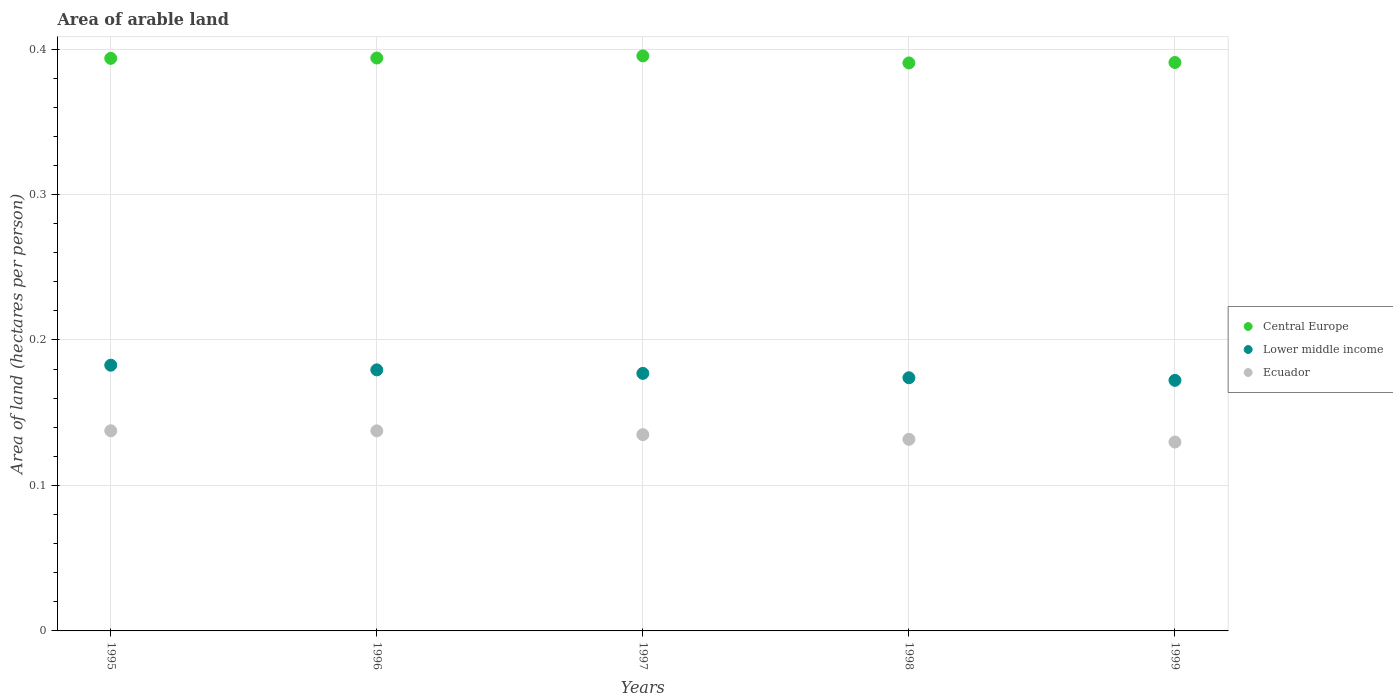What is the total arable land in Lower middle income in 1997?
Provide a succinct answer. 0.18. Across all years, what is the maximum total arable land in Central Europe?
Your answer should be compact. 0.4. Across all years, what is the minimum total arable land in Lower middle income?
Make the answer very short. 0.17. What is the total total arable land in Lower middle income in the graph?
Your answer should be compact. 0.89. What is the difference between the total arable land in Central Europe in 1995 and that in 1998?
Offer a terse response. 0. What is the difference between the total arable land in Lower middle income in 1998 and the total arable land in Ecuador in 1999?
Provide a succinct answer. 0.04. What is the average total arable land in Lower middle income per year?
Provide a short and direct response. 0.18. In the year 1995, what is the difference between the total arable land in Lower middle income and total arable land in Central Europe?
Ensure brevity in your answer.  -0.21. What is the ratio of the total arable land in Lower middle income in 1995 to that in 1998?
Your response must be concise. 1.05. Is the total arable land in Lower middle income in 1995 less than that in 1997?
Offer a terse response. No. What is the difference between the highest and the second highest total arable land in Lower middle income?
Make the answer very short. 0. What is the difference between the highest and the lowest total arable land in Ecuador?
Provide a short and direct response. 0.01. Is it the case that in every year, the sum of the total arable land in Lower middle income and total arable land in Ecuador  is greater than the total arable land in Central Europe?
Offer a terse response. No. Does the total arable land in Central Europe monotonically increase over the years?
Provide a succinct answer. No. Is the total arable land in Central Europe strictly greater than the total arable land in Lower middle income over the years?
Your answer should be compact. Yes. Is the total arable land in Ecuador strictly less than the total arable land in Central Europe over the years?
Your answer should be very brief. Yes. What is the title of the graph?
Make the answer very short. Area of arable land. What is the label or title of the Y-axis?
Keep it short and to the point. Area of land (hectares per person). What is the Area of land (hectares per person) of Central Europe in 1995?
Make the answer very short. 0.39. What is the Area of land (hectares per person) in Lower middle income in 1995?
Make the answer very short. 0.18. What is the Area of land (hectares per person) in Ecuador in 1995?
Give a very brief answer. 0.14. What is the Area of land (hectares per person) of Central Europe in 1996?
Ensure brevity in your answer.  0.39. What is the Area of land (hectares per person) in Lower middle income in 1996?
Keep it short and to the point. 0.18. What is the Area of land (hectares per person) in Ecuador in 1996?
Your response must be concise. 0.14. What is the Area of land (hectares per person) in Central Europe in 1997?
Your response must be concise. 0.4. What is the Area of land (hectares per person) in Lower middle income in 1997?
Provide a succinct answer. 0.18. What is the Area of land (hectares per person) of Ecuador in 1997?
Offer a very short reply. 0.13. What is the Area of land (hectares per person) in Central Europe in 1998?
Provide a short and direct response. 0.39. What is the Area of land (hectares per person) of Lower middle income in 1998?
Offer a very short reply. 0.17. What is the Area of land (hectares per person) in Ecuador in 1998?
Offer a very short reply. 0.13. What is the Area of land (hectares per person) in Central Europe in 1999?
Keep it short and to the point. 0.39. What is the Area of land (hectares per person) of Lower middle income in 1999?
Ensure brevity in your answer.  0.17. What is the Area of land (hectares per person) of Ecuador in 1999?
Your response must be concise. 0.13. Across all years, what is the maximum Area of land (hectares per person) of Central Europe?
Offer a terse response. 0.4. Across all years, what is the maximum Area of land (hectares per person) in Lower middle income?
Offer a very short reply. 0.18. Across all years, what is the maximum Area of land (hectares per person) of Ecuador?
Offer a very short reply. 0.14. Across all years, what is the minimum Area of land (hectares per person) of Central Europe?
Provide a short and direct response. 0.39. Across all years, what is the minimum Area of land (hectares per person) in Lower middle income?
Your answer should be compact. 0.17. Across all years, what is the minimum Area of land (hectares per person) in Ecuador?
Ensure brevity in your answer.  0.13. What is the total Area of land (hectares per person) in Central Europe in the graph?
Your response must be concise. 1.96. What is the total Area of land (hectares per person) of Lower middle income in the graph?
Your response must be concise. 0.89. What is the total Area of land (hectares per person) in Ecuador in the graph?
Keep it short and to the point. 0.67. What is the difference between the Area of land (hectares per person) of Central Europe in 1995 and that in 1996?
Give a very brief answer. -0. What is the difference between the Area of land (hectares per person) in Lower middle income in 1995 and that in 1996?
Your response must be concise. 0. What is the difference between the Area of land (hectares per person) of Ecuador in 1995 and that in 1996?
Offer a terse response. 0. What is the difference between the Area of land (hectares per person) in Central Europe in 1995 and that in 1997?
Provide a short and direct response. -0. What is the difference between the Area of land (hectares per person) of Lower middle income in 1995 and that in 1997?
Your answer should be very brief. 0.01. What is the difference between the Area of land (hectares per person) in Ecuador in 1995 and that in 1997?
Your response must be concise. 0. What is the difference between the Area of land (hectares per person) in Central Europe in 1995 and that in 1998?
Make the answer very short. 0. What is the difference between the Area of land (hectares per person) of Lower middle income in 1995 and that in 1998?
Make the answer very short. 0.01. What is the difference between the Area of land (hectares per person) of Ecuador in 1995 and that in 1998?
Your answer should be compact. 0.01. What is the difference between the Area of land (hectares per person) of Central Europe in 1995 and that in 1999?
Provide a succinct answer. 0. What is the difference between the Area of land (hectares per person) in Lower middle income in 1995 and that in 1999?
Make the answer very short. 0.01. What is the difference between the Area of land (hectares per person) in Ecuador in 1995 and that in 1999?
Ensure brevity in your answer.  0.01. What is the difference between the Area of land (hectares per person) in Central Europe in 1996 and that in 1997?
Provide a succinct answer. -0. What is the difference between the Area of land (hectares per person) in Lower middle income in 1996 and that in 1997?
Give a very brief answer. 0. What is the difference between the Area of land (hectares per person) of Ecuador in 1996 and that in 1997?
Provide a short and direct response. 0. What is the difference between the Area of land (hectares per person) of Central Europe in 1996 and that in 1998?
Your answer should be very brief. 0. What is the difference between the Area of land (hectares per person) of Lower middle income in 1996 and that in 1998?
Your answer should be very brief. 0.01. What is the difference between the Area of land (hectares per person) in Ecuador in 1996 and that in 1998?
Your response must be concise. 0.01. What is the difference between the Area of land (hectares per person) in Central Europe in 1996 and that in 1999?
Make the answer very short. 0. What is the difference between the Area of land (hectares per person) of Lower middle income in 1996 and that in 1999?
Make the answer very short. 0.01. What is the difference between the Area of land (hectares per person) of Ecuador in 1996 and that in 1999?
Provide a short and direct response. 0.01. What is the difference between the Area of land (hectares per person) in Central Europe in 1997 and that in 1998?
Your response must be concise. 0. What is the difference between the Area of land (hectares per person) in Lower middle income in 1997 and that in 1998?
Offer a very short reply. 0. What is the difference between the Area of land (hectares per person) in Ecuador in 1997 and that in 1998?
Give a very brief answer. 0. What is the difference between the Area of land (hectares per person) in Central Europe in 1997 and that in 1999?
Offer a terse response. 0. What is the difference between the Area of land (hectares per person) in Lower middle income in 1997 and that in 1999?
Ensure brevity in your answer.  0. What is the difference between the Area of land (hectares per person) of Ecuador in 1997 and that in 1999?
Keep it short and to the point. 0.01. What is the difference between the Area of land (hectares per person) in Central Europe in 1998 and that in 1999?
Ensure brevity in your answer.  -0. What is the difference between the Area of land (hectares per person) in Lower middle income in 1998 and that in 1999?
Provide a succinct answer. 0. What is the difference between the Area of land (hectares per person) in Ecuador in 1998 and that in 1999?
Keep it short and to the point. 0. What is the difference between the Area of land (hectares per person) of Central Europe in 1995 and the Area of land (hectares per person) of Lower middle income in 1996?
Ensure brevity in your answer.  0.21. What is the difference between the Area of land (hectares per person) of Central Europe in 1995 and the Area of land (hectares per person) of Ecuador in 1996?
Your answer should be compact. 0.26. What is the difference between the Area of land (hectares per person) in Lower middle income in 1995 and the Area of land (hectares per person) in Ecuador in 1996?
Offer a terse response. 0.05. What is the difference between the Area of land (hectares per person) in Central Europe in 1995 and the Area of land (hectares per person) in Lower middle income in 1997?
Your answer should be very brief. 0.22. What is the difference between the Area of land (hectares per person) of Central Europe in 1995 and the Area of land (hectares per person) of Ecuador in 1997?
Keep it short and to the point. 0.26. What is the difference between the Area of land (hectares per person) in Lower middle income in 1995 and the Area of land (hectares per person) in Ecuador in 1997?
Offer a terse response. 0.05. What is the difference between the Area of land (hectares per person) of Central Europe in 1995 and the Area of land (hectares per person) of Lower middle income in 1998?
Ensure brevity in your answer.  0.22. What is the difference between the Area of land (hectares per person) in Central Europe in 1995 and the Area of land (hectares per person) in Ecuador in 1998?
Keep it short and to the point. 0.26. What is the difference between the Area of land (hectares per person) of Lower middle income in 1995 and the Area of land (hectares per person) of Ecuador in 1998?
Provide a short and direct response. 0.05. What is the difference between the Area of land (hectares per person) of Central Europe in 1995 and the Area of land (hectares per person) of Lower middle income in 1999?
Give a very brief answer. 0.22. What is the difference between the Area of land (hectares per person) in Central Europe in 1995 and the Area of land (hectares per person) in Ecuador in 1999?
Your answer should be very brief. 0.26. What is the difference between the Area of land (hectares per person) of Lower middle income in 1995 and the Area of land (hectares per person) of Ecuador in 1999?
Your answer should be very brief. 0.05. What is the difference between the Area of land (hectares per person) in Central Europe in 1996 and the Area of land (hectares per person) in Lower middle income in 1997?
Keep it short and to the point. 0.22. What is the difference between the Area of land (hectares per person) of Central Europe in 1996 and the Area of land (hectares per person) of Ecuador in 1997?
Make the answer very short. 0.26. What is the difference between the Area of land (hectares per person) in Lower middle income in 1996 and the Area of land (hectares per person) in Ecuador in 1997?
Offer a terse response. 0.04. What is the difference between the Area of land (hectares per person) of Central Europe in 1996 and the Area of land (hectares per person) of Lower middle income in 1998?
Offer a terse response. 0.22. What is the difference between the Area of land (hectares per person) of Central Europe in 1996 and the Area of land (hectares per person) of Ecuador in 1998?
Make the answer very short. 0.26. What is the difference between the Area of land (hectares per person) in Lower middle income in 1996 and the Area of land (hectares per person) in Ecuador in 1998?
Your response must be concise. 0.05. What is the difference between the Area of land (hectares per person) in Central Europe in 1996 and the Area of land (hectares per person) in Lower middle income in 1999?
Make the answer very short. 0.22. What is the difference between the Area of land (hectares per person) in Central Europe in 1996 and the Area of land (hectares per person) in Ecuador in 1999?
Offer a very short reply. 0.26. What is the difference between the Area of land (hectares per person) of Lower middle income in 1996 and the Area of land (hectares per person) of Ecuador in 1999?
Provide a succinct answer. 0.05. What is the difference between the Area of land (hectares per person) in Central Europe in 1997 and the Area of land (hectares per person) in Lower middle income in 1998?
Keep it short and to the point. 0.22. What is the difference between the Area of land (hectares per person) in Central Europe in 1997 and the Area of land (hectares per person) in Ecuador in 1998?
Offer a terse response. 0.26. What is the difference between the Area of land (hectares per person) of Lower middle income in 1997 and the Area of land (hectares per person) of Ecuador in 1998?
Provide a succinct answer. 0.05. What is the difference between the Area of land (hectares per person) in Central Europe in 1997 and the Area of land (hectares per person) in Lower middle income in 1999?
Ensure brevity in your answer.  0.22. What is the difference between the Area of land (hectares per person) in Central Europe in 1997 and the Area of land (hectares per person) in Ecuador in 1999?
Your response must be concise. 0.27. What is the difference between the Area of land (hectares per person) in Lower middle income in 1997 and the Area of land (hectares per person) in Ecuador in 1999?
Your answer should be very brief. 0.05. What is the difference between the Area of land (hectares per person) of Central Europe in 1998 and the Area of land (hectares per person) of Lower middle income in 1999?
Make the answer very short. 0.22. What is the difference between the Area of land (hectares per person) in Central Europe in 1998 and the Area of land (hectares per person) in Ecuador in 1999?
Give a very brief answer. 0.26. What is the difference between the Area of land (hectares per person) in Lower middle income in 1998 and the Area of land (hectares per person) in Ecuador in 1999?
Keep it short and to the point. 0.04. What is the average Area of land (hectares per person) in Central Europe per year?
Give a very brief answer. 0.39. What is the average Area of land (hectares per person) in Lower middle income per year?
Provide a short and direct response. 0.18. What is the average Area of land (hectares per person) of Ecuador per year?
Keep it short and to the point. 0.13. In the year 1995, what is the difference between the Area of land (hectares per person) in Central Europe and Area of land (hectares per person) in Lower middle income?
Ensure brevity in your answer.  0.21. In the year 1995, what is the difference between the Area of land (hectares per person) in Central Europe and Area of land (hectares per person) in Ecuador?
Your answer should be very brief. 0.26. In the year 1995, what is the difference between the Area of land (hectares per person) of Lower middle income and Area of land (hectares per person) of Ecuador?
Offer a terse response. 0.05. In the year 1996, what is the difference between the Area of land (hectares per person) of Central Europe and Area of land (hectares per person) of Lower middle income?
Your answer should be compact. 0.21. In the year 1996, what is the difference between the Area of land (hectares per person) of Central Europe and Area of land (hectares per person) of Ecuador?
Your answer should be compact. 0.26. In the year 1996, what is the difference between the Area of land (hectares per person) in Lower middle income and Area of land (hectares per person) in Ecuador?
Offer a terse response. 0.04. In the year 1997, what is the difference between the Area of land (hectares per person) in Central Europe and Area of land (hectares per person) in Lower middle income?
Your answer should be compact. 0.22. In the year 1997, what is the difference between the Area of land (hectares per person) in Central Europe and Area of land (hectares per person) in Ecuador?
Provide a succinct answer. 0.26. In the year 1997, what is the difference between the Area of land (hectares per person) of Lower middle income and Area of land (hectares per person) of Ecuador?
Ensure brevity in your answer.  0.04. In the year 1998, what is the difference between the Area of land (hectares per person) of Central Europe and Area of land (hectares per person) of Lower middle income?
Your response must be concise. 0.22. In the year 1998, what is the difference between the Area of land (hectares per person) in Central Europe and Area of land (hectares per person) in Ecuador?
Offer a terse response. 0.26. In the year 1998, what is the difference between the Area of land (hectares per person) of Lower middle income and Area of land (hectares per person) of Ecuador?
Your answer should be very brief. 0.04. In the year 1999, what is the difference between the Area of land (hectares per person) of Central Europe and Area of land (hectares per person) of Lower middle income?
Make the answer very short. 0.22. In the year 1999, what is the difference between the Area of land (hectares per person) of Central Europe and Area of land (hectares per person) of Ecuador?
Give a very brief answer. 0.26. In the year 1999, what is the difference between the Area of land (hectares per person) of Lower middle income and Area of land (hectares per person) of Ecuador?
Your response must be concise. 0.04. What is the ratio of the Area of land (hectares per person) in Central Europe in 1995 to that in 1996?
Make the answer very short. 1. What is the ratio of the Area of land (hectares per person) in Lower middle income in 1995 to that in 1996?
Offer a terse response. 1.02. What is the ratio of the Area of land (hectares per person) in Central Europe in 1995 to that in 1997?
Make the answer very short. 1. What is the ratio of the Area of land (hectares per person) in Lower middle income in 1995 to that in 1997?
Offer a terse response. 1.03. What is the ratio of the Area of land (hectares per person) in Ecuador in 1995 to that in 1997?
Offer a terse response. 1.02. What is the ratio of the Area of land (hectares per person) in Central Europe in 1995 to that in 1998?
Keep it short and to the point. 1.01. What is the ratio of the Area of land (hectares per person) in Lower middle income in 1995 to that in 1998?
Offer a terse response. 1.05. What is the ratio of the Area of land (hectares per person) of Ecuador in 1995 to that in 1998?
Provide a short and direct response. 1.04. What is the ratio of the Area of land (hectares per person) of Central Europe in 1995 to that in 1999?
Your answer should be very brief. 1.01. What is the ratio of the Area of land (hectares per person) in Lower middle income in 1995 to that in 1999?
Make the answer very short. 1.06. What is the ratio of the Area of land (hectares per person) in Ecuador in 1995 to that in 1999?
Your answer should be compact. 1.06. What is the ratio of the Area of land (hectares per person) of Lower middle income in 1996 to that in 1997?
Make the answer very short. 1.01. What is the ratio of the Area of land (hectares per person) of Ecuador in 1996 to that in 1997?
Your answer should be compact. 1.02. What is the ratio of the Area of land (hectares per person) in Central Europe in 1996 to that in 1998?
Your answer should be compact. 1.01. What is the ratio of the Area of land (hectares per person) of Lower middle income in 1996 to that in 1998?
Ensure brevity in your answer.  1.03. What is the ratio of the Area of land (hectares per person) of Ecuador in 1996 to that in 1998?
Make the answer very short. 1.04. What is the ratio of the Area of land (hectares per person) of Central Europe in 1996 to that in 1999?
Offer a very short reply. 1.01. What is the ratio of the Area of land (hectares per person) of Lower middle income in 1996 to that in 1999?
Make the answer very short. 1.04. What is the ratio of the Area of land (hectares per person) in Ecuador in 1996 to that in 1999?
Keep it short and to the point. 1.06. What is the ratio of the Area of land (hectares per person) in Central Europe in 1997 to that in 1998?
Offer a terse response. 1.01. What is the ratio of the Area of land (hectares per person) in Lower middle income in 1997 to that in 1998?
Offer a terse response. 1.02. What is the ratio of the Area of land (hectares per person) in Ecuador in 1997 to that in 1998?
Provide a succinct answer. 1.02. What is the ratio of the Area of land (hectares per person) in Central Europe in 1997 to that in 1999?
Your answer should be very brief. 1.01. What is the ratio of the Area of land (hectares per person) of Lower middle income in 1997 to that in 1999?
Ensure brevity in your answer.  1.03. What is the ratio of the Area of land (hectares per person) of Ecuador in 1997 to that in 1999?
Offer a very short reply. 1.04. What is the ratio of the Area of land (hectares per person) in Central Europe in 1998 to that in 1999?
Your response must be concise. 1. What is the ratio of the Area of land (hectares per person) of Lower middle income in 1998 to that in 1999?
Ensure brevity in your answer.  1.01. What is the ratio of the Area of land (hectares per person) in Ecuador in 1998 to that in 1999?
Make the answer very short. 1.01. What is the difference between the highest and the second highest Area of land (hectares per person) of Central Europe?
Your response must be concise. 0. What is the difference between the highest and the second highest Area of land (hectares per person) in Lower middle income?
Make the answer very short. 0. What is the difference between the highest and the second highest Area of land (hectares per person) of Ecuador?
Keep it short and to the point. 0. What is the difference between the highest and the lowest Area of land (hectares per person) in Central Europe?
Keep it short and to the point. 0. What is the difference between the highest and the lowest Area of land (hectares per person) of Lower middle income?
Provide a short and direct response. 0.01. What is the difference between the highest and the lowest Area of land (hectares per person) of Ecuador?
Provide a short and direct response. 0.01. 